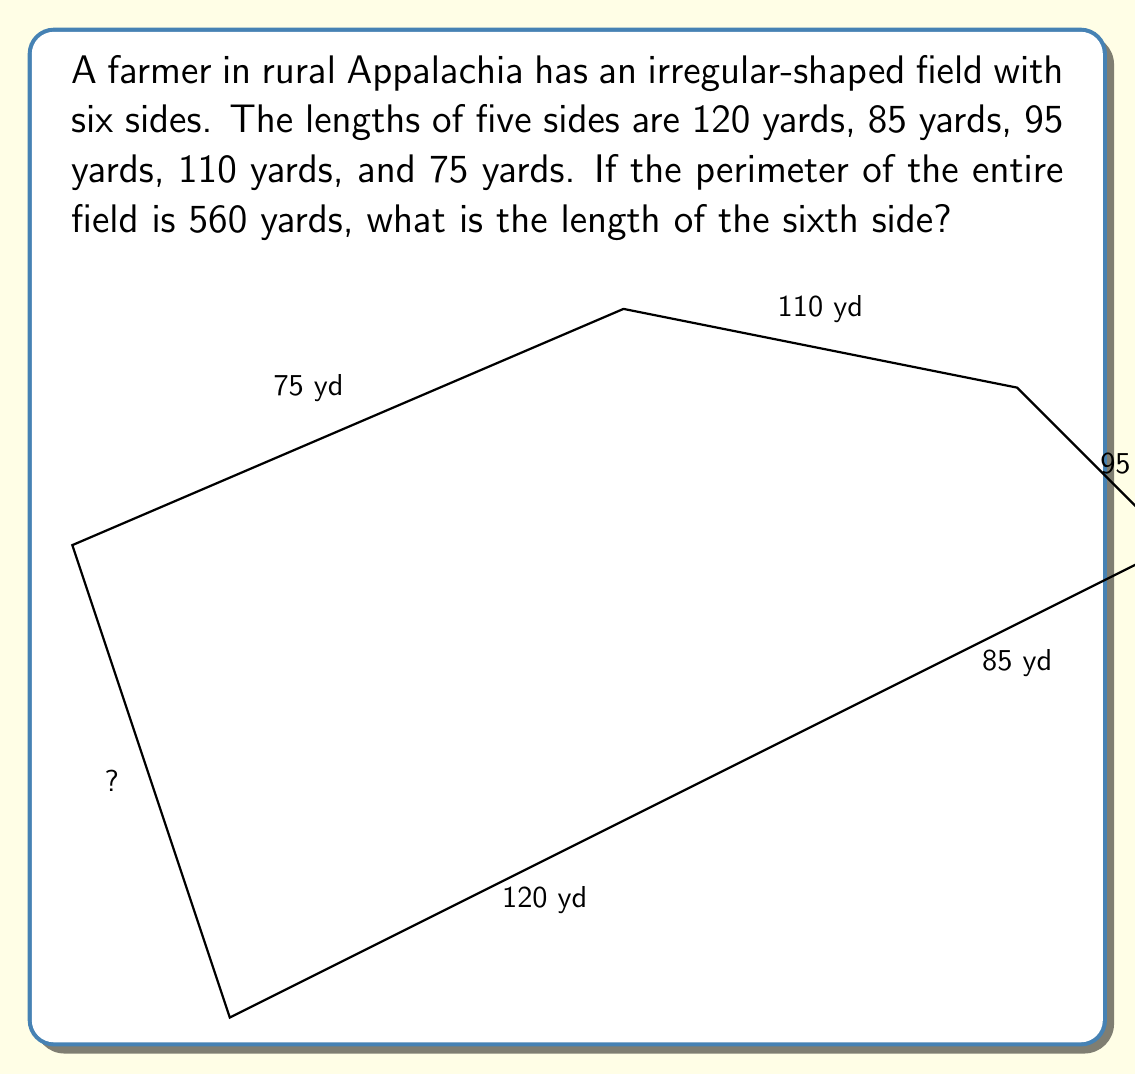Can you solve this math problem? Let's approach this step-by-step:

1) First, we need to understand what perimeter means. The perimeter is the total distance around the outside of a shape.

2) We're given that the perimeter of the entire field is 560 yards.

3) We're also given the lengths of five sides:
   - Side 1: 120 yards
   - Side 2: 85 yards
   - Side 3: 95 yards
   - Side 4: 110 yards
   - Side 5: 75 yards

4) To find the length of the sixth side, we can use the following equation:
   $$ \text{Perimeter} = \text{Sum of all sides} $$

5) Let's call the unknown side length $x$. We can now set up an equation:
   $$ 560 = 120 + 85 + 95 + 110 + 75 + x $$

6) Simplify the known side lengths:
   $$ 560 = 485 + x $$

7) Subtract 485 from both sides:
   $$ 560 - 485 = x $$

8) Simplify:
   $$ 75 = x $$

Therefore, the length of the sixth side is 75 yards.
Answer: 75 yards 